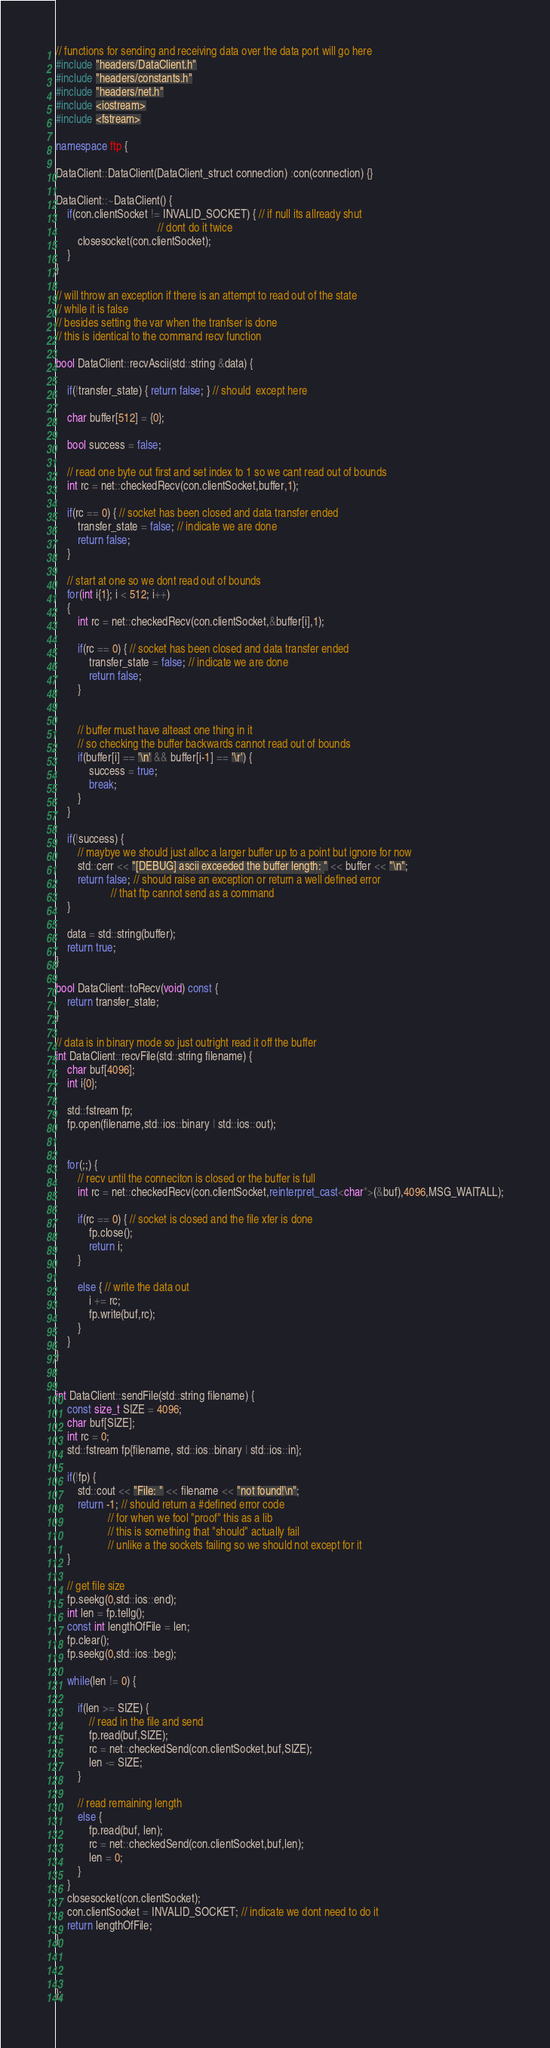Convert code to text. <code><loc_0><loc_0><loc_500><loc_500><_C++_>// functions for sending and receiving data over the data port will go here
#include "headers/DataClient.h"
#include "headers/constants.h"
#include "headers/net.h"
#include <iostream>
#include <fstream>

namespace ftp {

DataClient::DataClient(DataClient_struct connection) :con(connection) {}

DataClient::~DataClient() {
	if(con.clientSocket != INVALID_SOCKET) { // if null its allready shut 
									 // dont do it twice
		closesocket(con.clientSocket);
	}
}

// will throw an exception if there is an attempt to read out of the state
// while it is false
// besides setting the var when the tranfser is done 
// this is identical to the command recv function 

bool DataClient::recvAscii(std::string &data) {
	
	if(!transfer_state) { return false; } // should  except here
	
	char buffer[512] = {0};
	
	bool success = false;

	// read one byte out first and set index to 1 so we cant read out of bounds
	int rc = net::checkedRecv(con.clientSocket,buffer,1);
		
	if(rc == 0) { // socket has been closed and data transfer ended
		transfer_state = false; // indicate we are done
		return false;
	}

	// start at one so we dont read out of bounds
	for(int i{1}; i < 512; i++)
	{
		int rc = net::checkedRecv(con.clientSocket,&buffer[i],1);
		
		if(rc == 0) { // socket has been closed and data transfer ended
			transfer_state = false; // indicate we are done
			return false;
		}
	

		// buffer must have alteast one thing in it 
		// so checking the buffer backwards cannot read out of bounds
		if(buffer[i] == '\n' && buffer[i-1] == '\r') {
			success = true;
			break;
		}
	}

	if(!success) {
		// maybye we should just alloc a larger buffer up to a point but ignore for now
		std::cerr << "[DEBUG] ascii exceeded the buffer length: " << buffer << "\n";
		return false; // should raise an exception or return a well defined error
					// that ftp cannot send as a command
	}
	
	data = std::string(buffer);
	return true;	
}

bool DataClient::toRecv(void) const {
	return transfer_state;
}

// data is in binary mode so just outright read it off the buffer
int DataClient::recvFile(std::string filename) {
	char buf[4096];
	int i{0};
	
	std::fstream fp;
	fp.open(filename,std::ios::binary | std::ios::out);
	
	
	for(;;) {
		// recv until the conneciton is closed or the buffer is full
		int rc = net::checkedRecv(con.clientSocket,reinterpret_cast<char*>(&buf),4096,MSG_WAITALL);
	
		if(rc == 0) { // socket is closed and the file xfer is done 
			fp.close();
			return i;
		}
		
		else { // write the data out
			i += rc;
			fp.write(buf,rc);
		}
	}
}


int DataClient::sendFile(std::string filename) {
	const size_t SIZE = 4096;
	char buf[SIZE];
	int rc = 0;
	std::fstream fp{filename, std::ios::binary | std::ios::in};
	
	if(!fp) {
		std::cout << "File: " << filename << "not found!\n";
		return -1; // should return a #defined error code
				   // for when we fool "proof" this as a lib
				   // this is something that "should" actually fail 
				   // unlike a the sockets failing so we should not except for it
	}
	
	// get file size
	fp.seekg(0,std::ios::end);
	int len = fp.tellg();
	const int lengthOfFile = len;
	fp.clear();
	fp.seekg(0,std::ios::beg);
	
	while(len != 0) {
	
		if(len >= SIZE) {
			// read in the file and send 
			fp.read(buf,SIZE);
			rc = net::checkedSend(con.clientSocket,buf,SIZE);
			len -= SIZE;
		}
		
		// read remaining length
		else {
			fp.read(buf, len);
			rc = net::checkedSend(con.clientSocket,buf,len);
			len = 0;
		}	
	}
	closesocket(con.clientSocket);
	con.clientSocket = INVALID_SOCKET; // indicate we dont need to do it 
	return lengthOfFile;
}



};</code> 